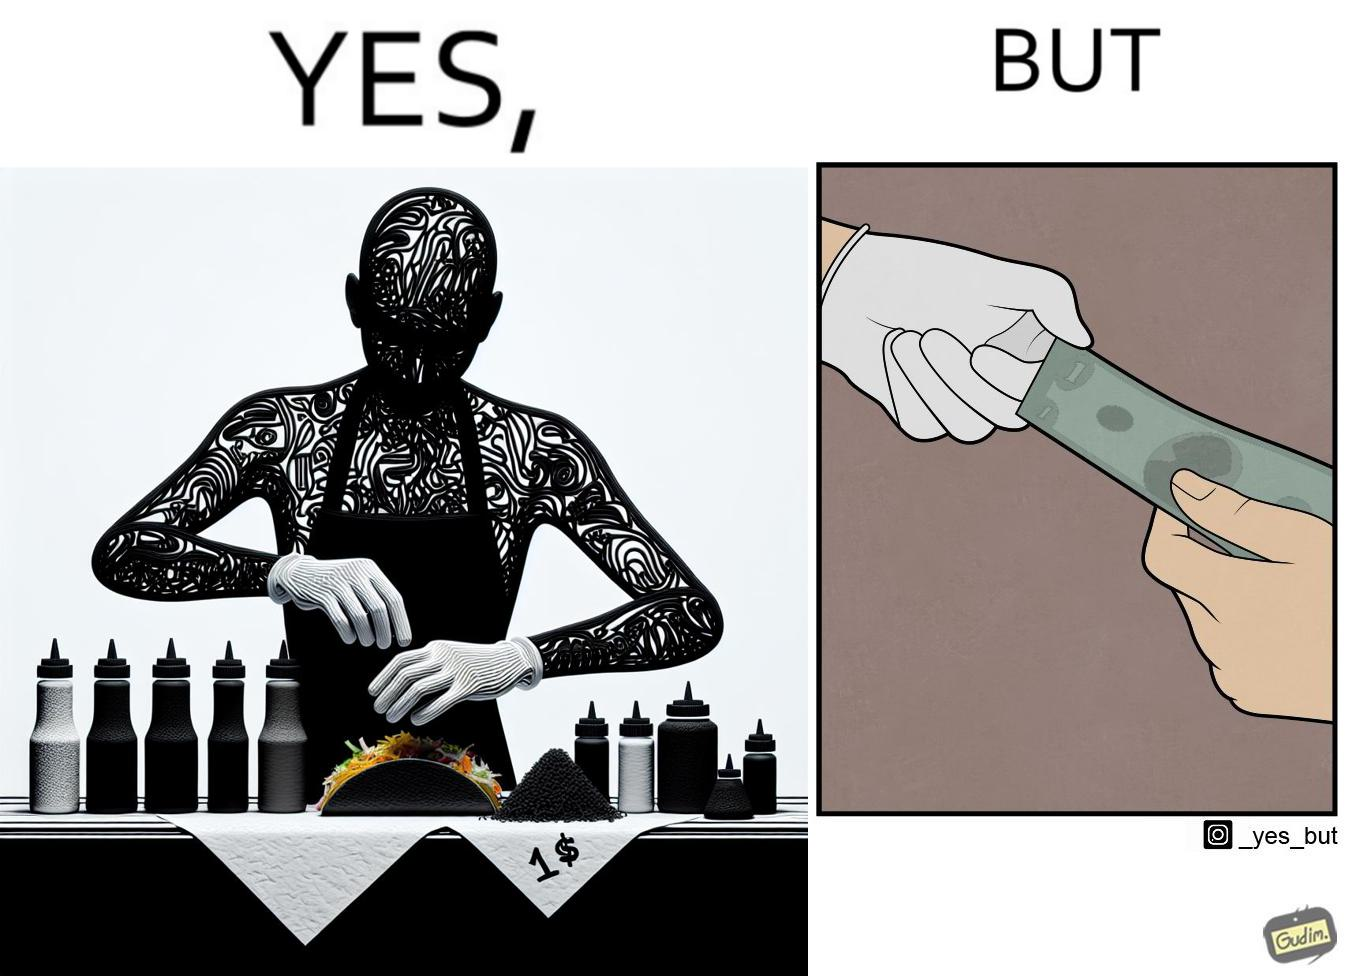Compare the left and right sides of this image. In the left part of the image: The image shows a person wearing white gloves preparing a taco in their hand. There are several condiments on the table. There is also a note that says "TACO 1$" indicating that each taco is sold for only $1. In the right part of the image: The image shows two people transacting $1 among them. One of them is wearing white gloves and one of them is not wearing any gloves. 